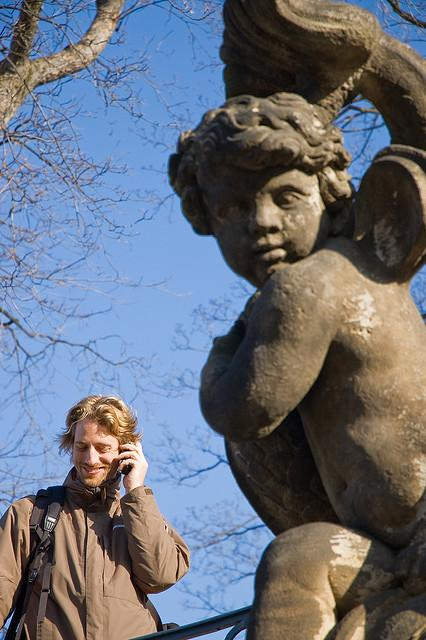What is the grey statue supposed to be?

Choices:
A) god
B) angel
C) ghost
D) demon angel 